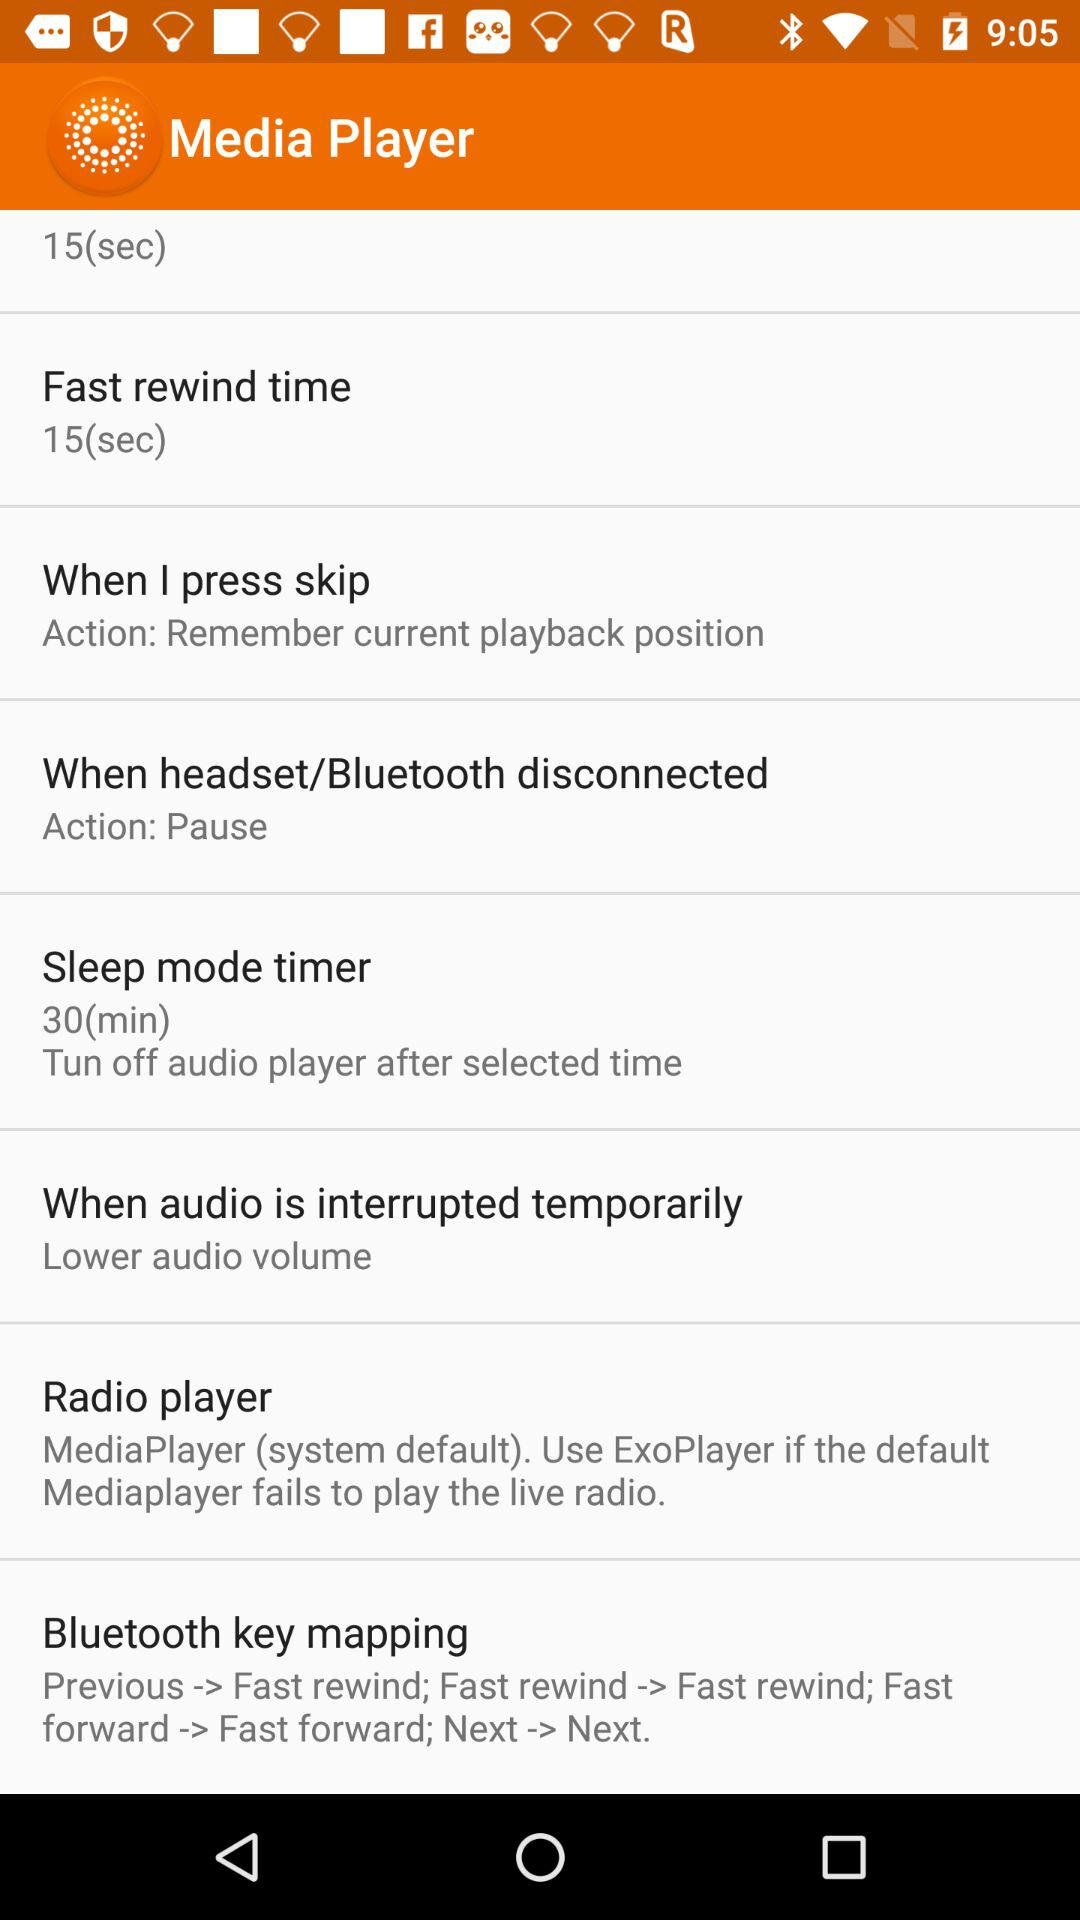What's the fast rewind time? The fast rewind time is 15 seconds. 